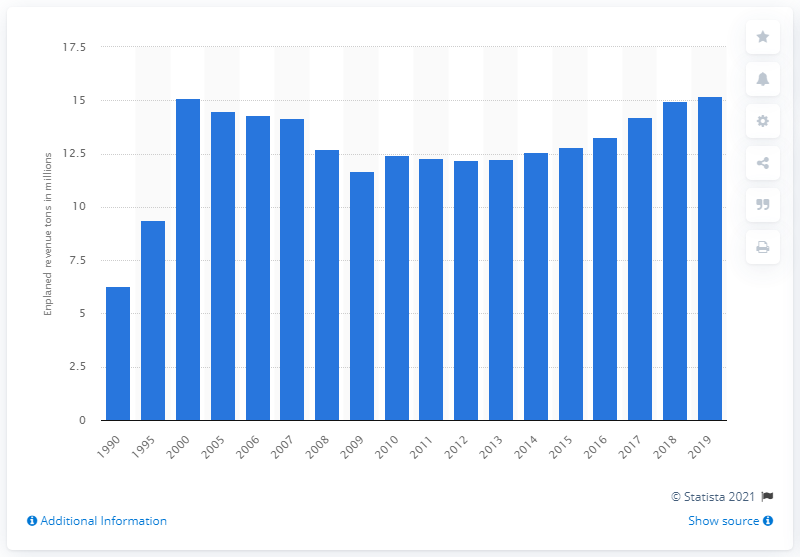Indicate a few pertinent items in this graphic. In 2019, U.S. air carriers transported 15.19 million short tons of freight and mail. 